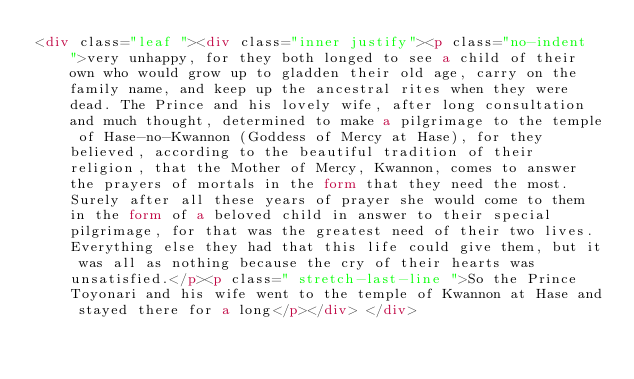<code> <loc_0><loc_0><loc_500><loc_500><_HTML_><div class="leaf "><div class="inner justify"><p class="no-indent  ">very unhappy, for they both longed to see a child of their own who would grow up to gladden their old age, carry on the family name, and keep up the ancestral rites when they were dead. The Prince and his lovely wife, after long consultation and much thought, determined to make a pilgrimage to the temple of Hase-no-Kwannon (Goddess of Mercy at Hase), for they believed, according to the beautiful tradition of their religion, that the Mother of Mercy, Kwannon, comes to answer the prayers of mortals in the form that they need the most. Surely after all these years of prayer she would come to them in the form of a beloved child in answer to their special pilgrimage, for that was the greatest need of their two lives. Everything else they had that this life could give them, but it was all as nothing because the cry of their hearts was unsatisfied.</p><p class=" stretch-last-line ">So the Prince Toyonari and his wife went to the temple of Kwannon at Hase and stayed there for a long</p></div> </div></code> 